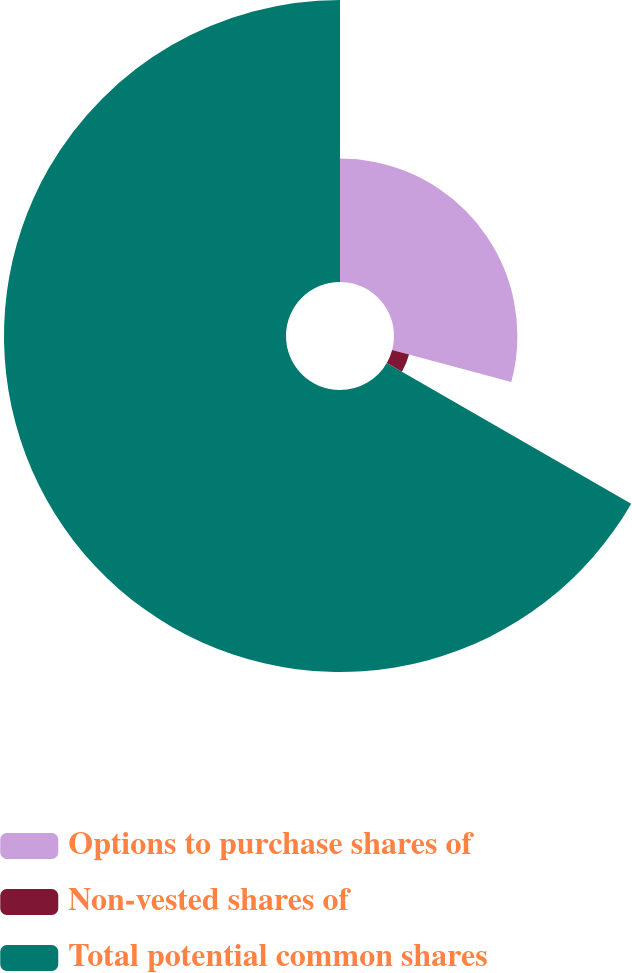Convert chart. <chart><loc_0><loc_0><loc_500><loc_500><pie_chart><fcel>Options to purchase shares of<fcel>Non-vested shares of<fcel>Total potential common shares<nl><fcel>29.18%<fcel>4.13%<fcel>66.68%<nl></chart> 